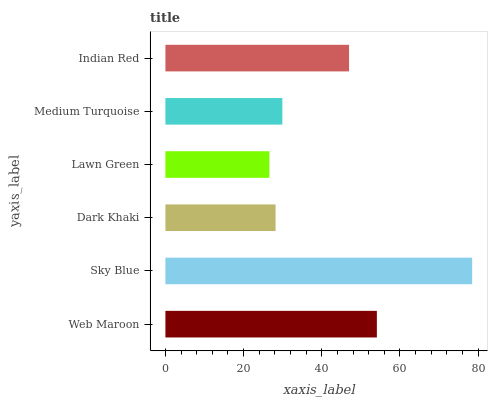Is Lawn Green the minimum?
Answer yes or no. Yes. Is Sky Blue the maximum?
Answer yes or no. Yes. Is Dark Khaki the minimum?
Answer yes or no. No. Is Dark Khaki the maximum?
Answer yes or no. No. Is Sky Blue greater than Dark Khaki?
Answer yes or no. Yes. Is Dark Khaki less than Sky Blue?
Answer yes or no. Yes. Is Dark Khaki greater than Sky Blue?
Answer yes or no. No. Is Sky Blue less than Dark Khaki?
Answer yes or no. No. Is Indian Red the high median?
Answer yes or no. Yes. Is Medium Turquoise the low median?
Answer yes or no. Yes. Is Dark Khaki the high median?
Answer yes or no. No. Is Web Maroon the low median?
Answer yes or no. No. 